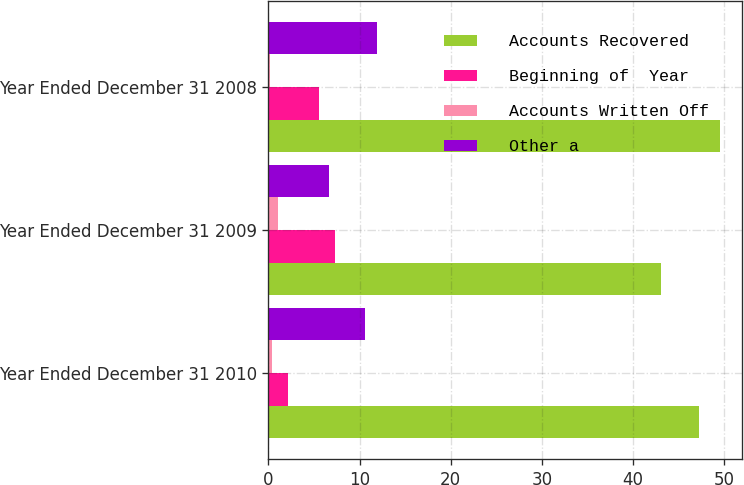Convert chart to OTSL. <chart><loc_0><loc_0><loc_500><loc_500><stacked_bar_chart><ecel><fcel>Year Ended December 31 2010<fcel>Year Ended December 31 2009<fcel>Year Ended December 31 2008<nl><fcel>Accounts Recovered<fcel>47.2<fcel>43.1<fcel>49.5<nl><fcel>Beginning of  Year<fcel>2.2<fcel>7.3<fcel>5.5<nl><fcel>Accounts Written Off<fcel>0.4<fcel>1<fcel>0.2<nl><fcel>Other a<fcel>10.6<fcel>6.7<fcel>11.9<nl></chart> 